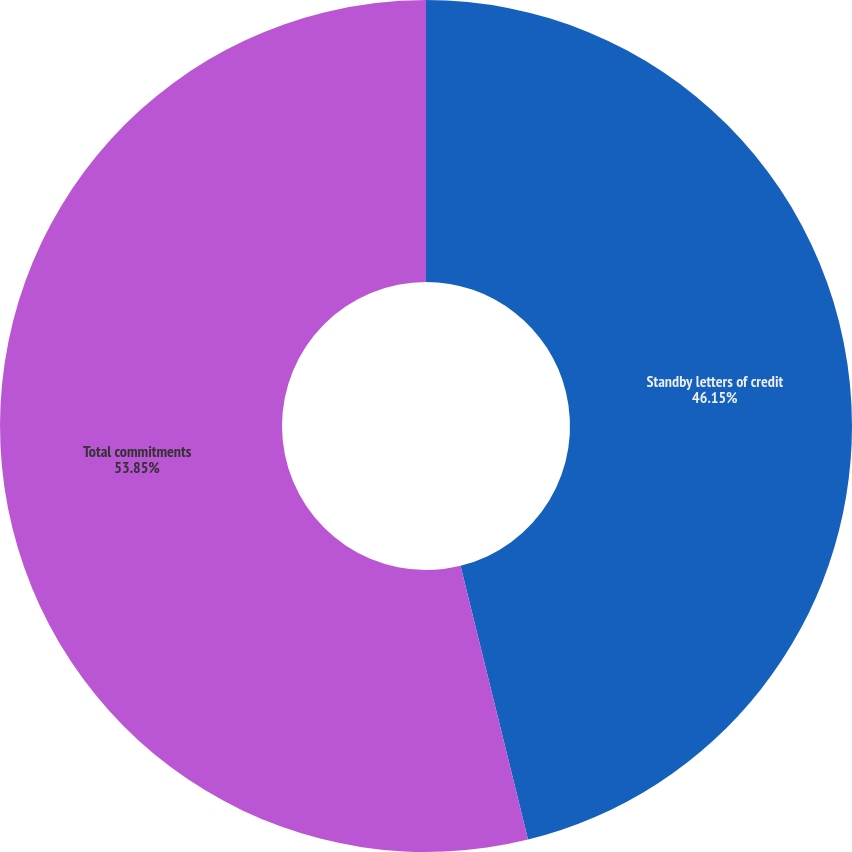<chart> <loc_0><loc_0><loc_500><loc_500><pie_chart><fcel>Standby letters of credit<fcel>Total commitments<nl><fcel>46.15%<fcel>53.85%<nl></chart> 